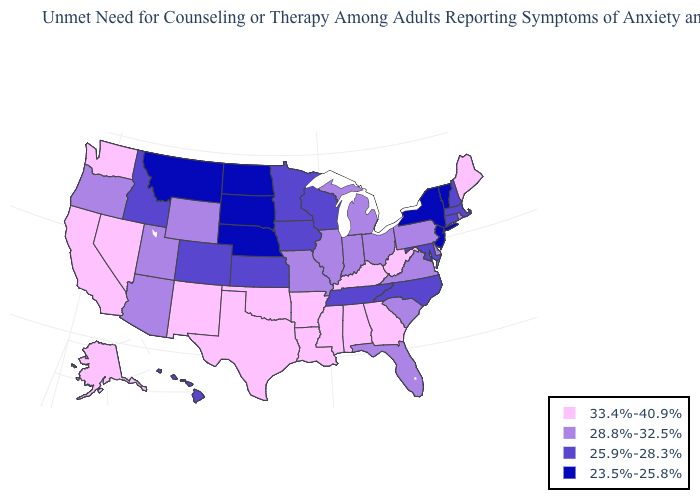Name the states that have a value in the range 25.9%-28.3%?
Short answer required. Colorado, Connecticut, Hawaii, Idaho, Iowa, Kansas, Maryland, Massachusetts, Minnesota, New Hampshire, North Carolina, Tennessee, Wisconsin. What is the value of Alabama?
Concise answer only. 33.4%-40.9%. Name the states that have a value in the range 28.8%-32.5%?
Write a very short answer. Arizona, Delaware, Florida, Illinois, Indiana, Michigan, Missouri, Ohio, Oregon, Pennsylvania, Rhode Island, South Carolina, Utah, Virginia, Wyoming. Does Wyoming have a higher value than West Virginia?
Concise answer only. No. Does Idaho have a higher value than North Dakota?
Quick response, please. Yes. Name the states that have a value in the range 28.8%-32.5%?
Keep it brief. Arizona, Delaware, Florida, Illinois, Indiana, Michigan, Missouri, Ohio, Oregon, Pennsylvania, Rhode Island, South Carolina, Utah, Virginia, Wyoming. Name the states that have a value in the range 25.9%-28.3%?
Give a very brief answer. Colorado, Connecticut, Hawaii, Idaho, Iowa, Kansas, Maryland, Massachusetts, Minnesota, New Hampshire, North Carolina, Tennessee, Wisconsin. What is the value of Idaho?
Keep it brief. 25.9%-28.3%. Name the states that have a value in the range 25.9%-28.3%?
Short answer required. Colorado, Connecticut, Hawaii, Idaho, Iowa, Kansas, Maryland, Massachusetts, Minnesota, New Hampshire, North Carolina, Tennessee, Wisconsin. What is the value of Indiana?
Keep it brief. 28.8%-32.5%. Which states have the highest value in the USA?
Quick response, please. Alabama, Alaska, Arkansas, California, Georgia, Kentucky, Louisiana, Maine, Mississippi, Nevada, New Mexico, Oklahoma, Texas, Washington, West Virginia. What is the lowest value in the West?
Keep it brief. 23.5%-25.8%. Among the states that border Illinois , which have the highest value?
Quick response, please. Kentucky. What is the highest value in the USA?
Answer briefly. 33.4%-40.9%. What is the value of New Hampshire?
Concise answer only. 25.9%-28.3%. 